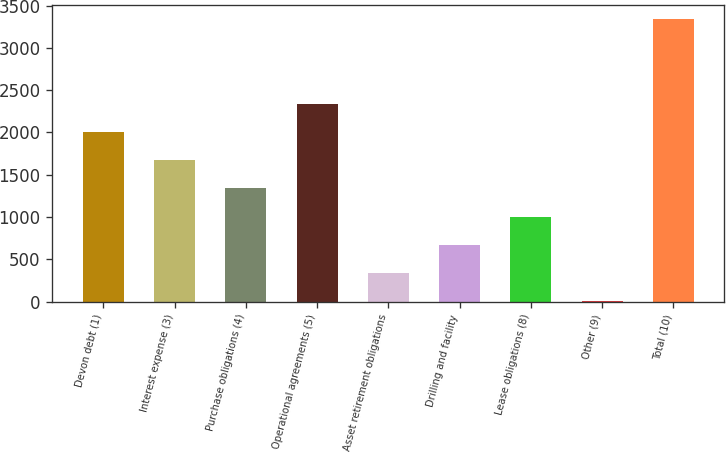Convert chart to OTSL. <chart><loc_0><loc_0><loc_500><loc_500><bar_chart><fcel>Devon debt (1)<fcel>Interest expense (3)<fcel>Purchase obligations (4)<fcel>Operational agreements (5)<fcel>Asset retirement obligations<fcel>Drilling and facility<fcel>Lease obligations (8)<fcel>Other (9)<fcel>Total (10)<nl><fcel>2006<fcel>1672<fcel>1338<fcel>2340<fcel>336<fcel>670<fcel>1004<fcel>2<fcel>3342<nl></chart> 